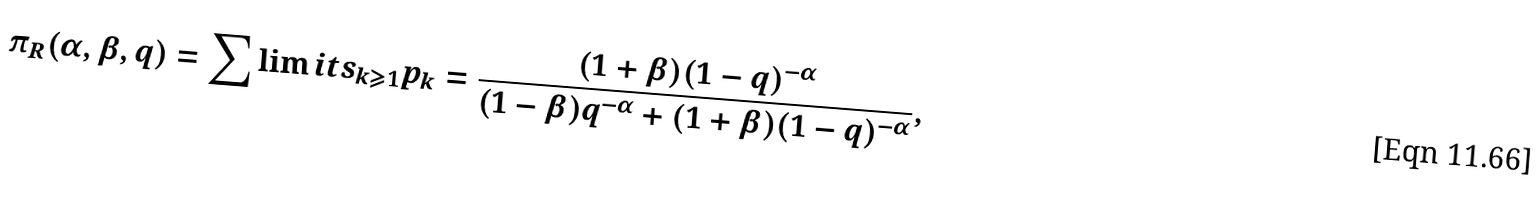Convert formula to latex. <formula><loc_0><loc_0><loc_500><loc_500>\pi _ { R } ( \alpha , \beta , q ) = \sum \lim i t s _ { k \geqslant 1 } p _ { k } = \frac { ( 1 + \beta ) ( 1 - q ) ^ { - \alpha } } { ( 1 - \beta ) q ^ { - \alpha } + ( 1 + \beta ) ( 1 - q ) ^ { - \alpha } } ,</formula> 